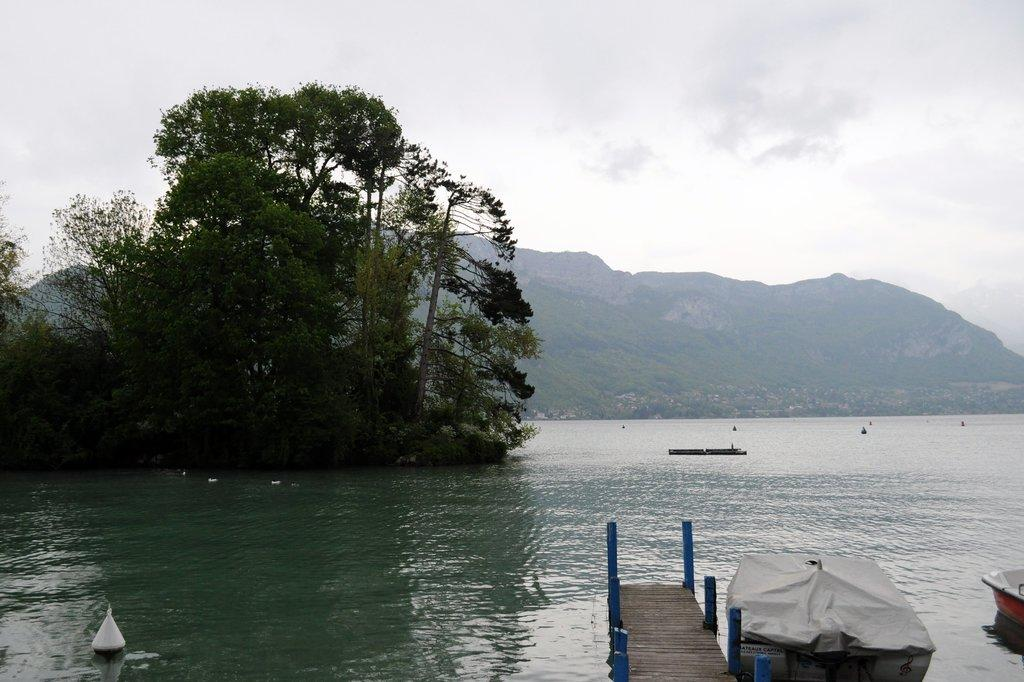What is on the water surface in the image? There are boats on the water surface in the image. What type of vegetation can be seen in the image? There are trees visible in the image. What can be seen in the distance in the image? There are hills in the background of the image. Can you tell me how many roses are on the boat in the image? There are no roses present in the image; it features boats on the water surface with trees and hills in the background. Is there a horse visible in the image? There is no horse present in the image. 